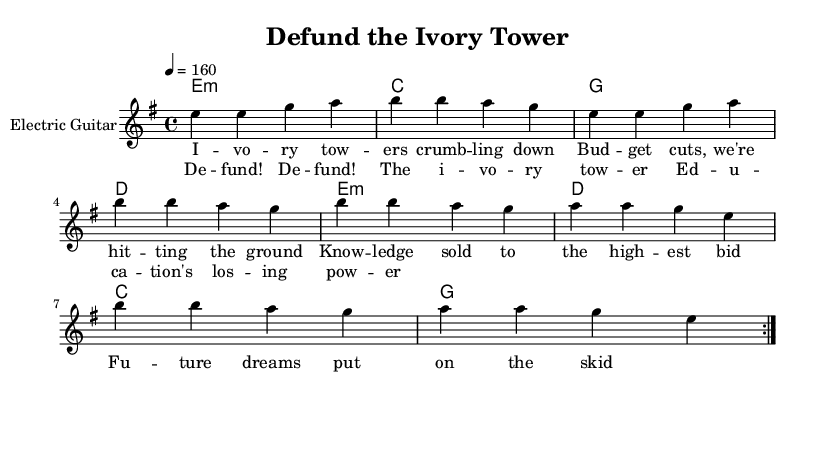What key is this piece in? The key signature is indicated at the beginning of the score, which is E minor, characterized by one sharp (F#).
Answer: E minor What is the time signature? The time signature is placed at the beginning of the score, showing that it is 4/4, meaning there are four beats in a measure and the quarter note gets one beat.
Answer: 4/4 What is the tempo marking? The tempo marking, shown at the beginning of the score, indicates the piece should be played at a speed of 160 beats per minute, typical for fast-paced music.
Answer: 160 How many measures are in the verse? By counting the measures in the melody section listed for the verse, there are a total of 8 measures repeated, as indicated by the repeated volta notation.
Answer: 8 What is the primary theme of the lyrics? Reviewing the lyrics presented in the verse, the primary theme critiques funding cuts in higher education, reflecting a protest against the current state of educational support.
Answer: Funding cuts What is the mood conveyed by the chorus? The chorus lyrics emphasize urgency and a call to action regarding the need to defund the "ivory tower," suggesting a rebellious and assertive mood typical in punk music.
Answer: Urgency What type of instrument is featured in the score? The instrument name indicated in the score is "Electric Guitar," a staple in punk music to provide a loud and aggressive sound.
Answer: Electric Guitar 